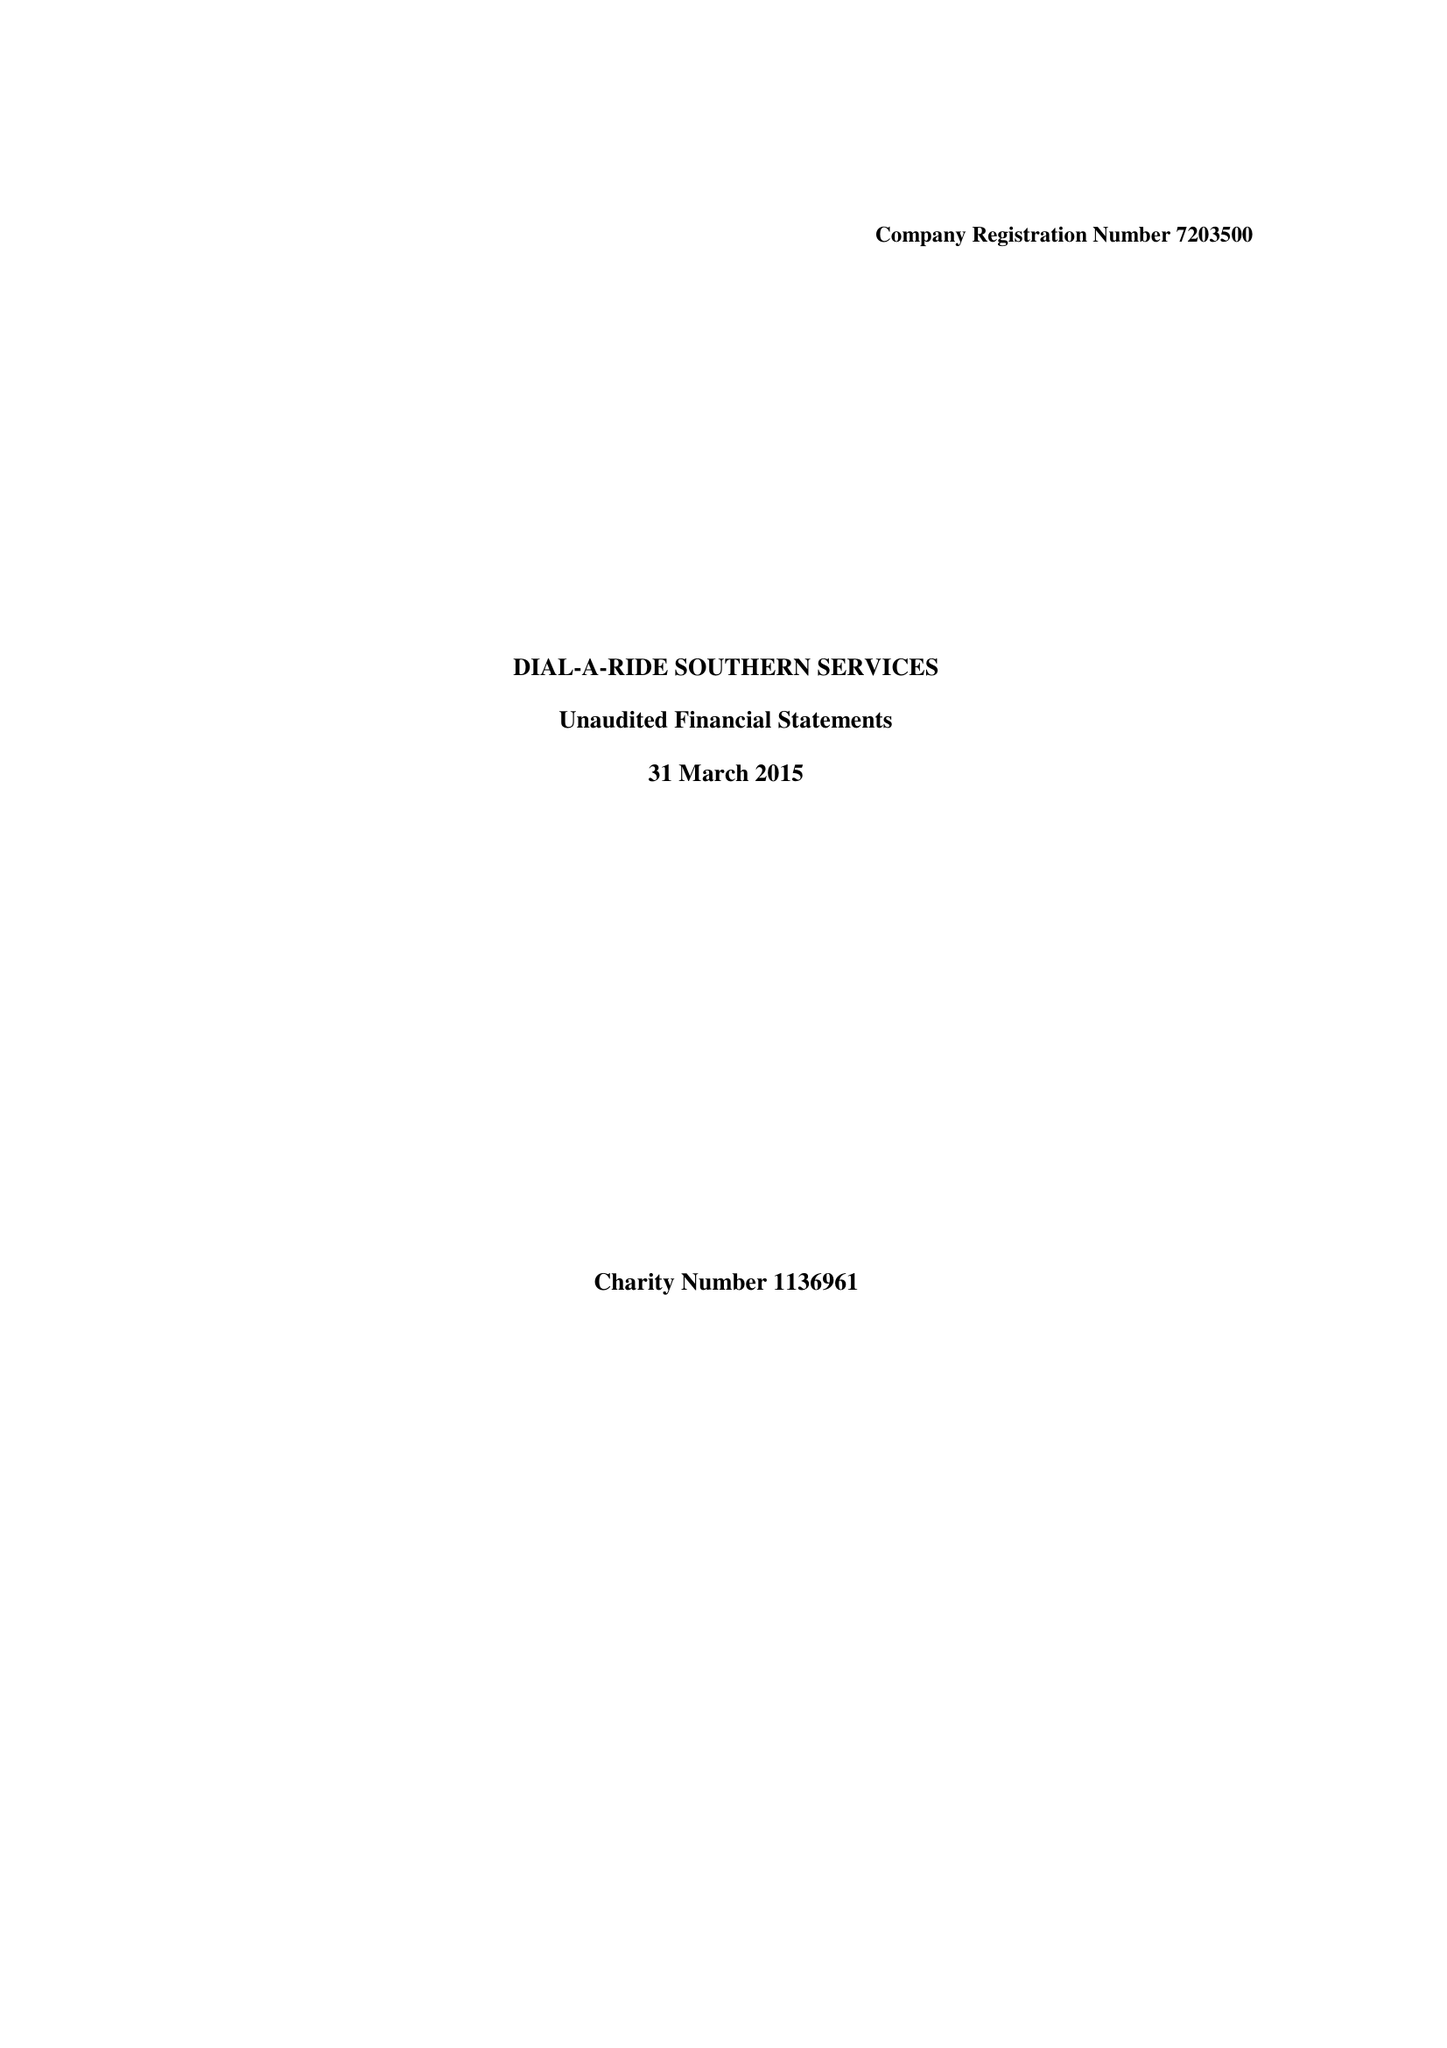What is the value for the report_date?
Answer the question using a single word or phrase. 2015-03-31 